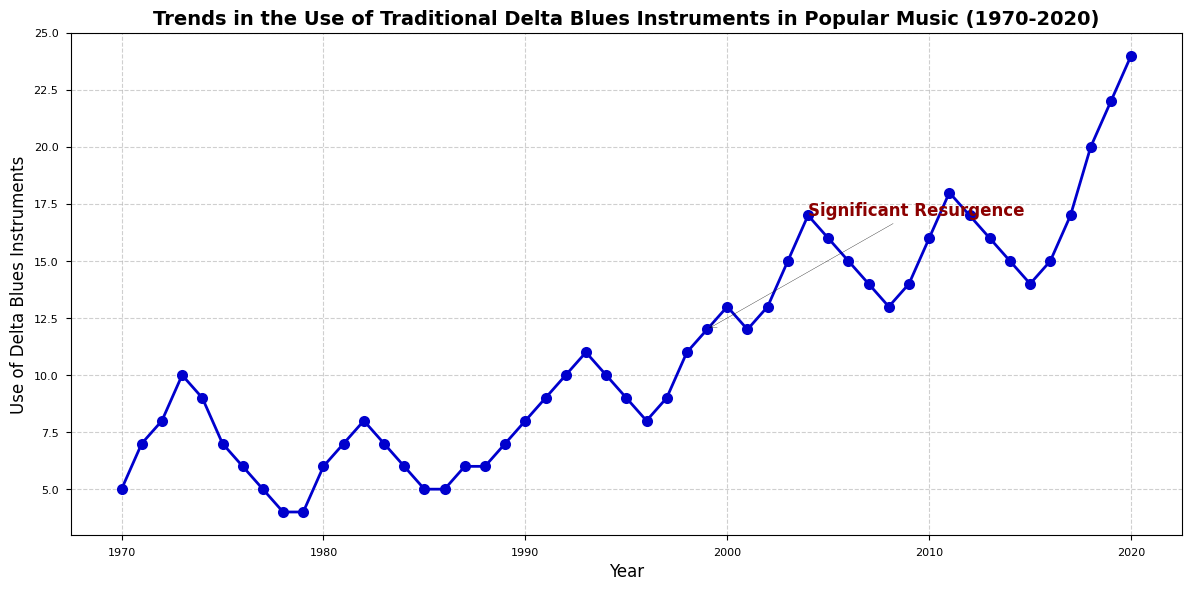What year had the highest use of Delta blues instruments? Looking at the chart, the year 2020 shows the highest point on the y-axis, indicating the highest use of Delta blues instruments.
Answer: 2020 In which year was there a significant resurgence noted in the use of Delta blues instruments? According to the annotation on the figure, the year 1999 is marked as the significant resurgence year.
Answer: 1999 By how much did the use of Delta blues instruments increase from 1978 to 1982? The use in 1978 was 4, and in 1982 it was 8. The difference between 8 and 4 is 4.
Answer: 4 Which year saw a greater increase in the use of Delta blues instruments: from 2000 to 2003 or from 2017 to 2020? From 2000 to 2003, the use increased from 13 to 15 (an increase of 2). From 2017 to 2020, it increased from 17 to 24 (an increase of 7). Thus, 2017 to 2020 saw a greater increase.
Answer: 2017 to 2020 What was the average use of Delta blues instruments in the first decade (1970-1979)? The values for 1970-1979 are: 5, 7, 8, 10, 9, 7, 6, 5, 4, 4. Summing these values gives 65, and there are 10 values. So, the average is 65/10 = 6.5.
Answer: 6.5 How did the use of Delta blues instruments change between 1989 and 1990? In 1989, the value was 7, and in 1990, it was 8. The use increased by 1.
Answer: Increased by 1 Is the trend from 2010 to 2015 increasing, decreasing, or fluctuating? From 2010 to 2015, the values are 16, 18, 17, 16, 15, 14. The trend is overall decreasing.
Answer: Decreasing What period had the most drastic increase in the use of Delta blues instruments? The most drastic increase appears to occur from 2016 (15) to 2018 (20), which is a difference of 5 within two years.
Answer: 2016 to 2018 How many times does the use of Delta blues instruments reach or surpass 20 units? The chart shows that the use reaches or surpasses 20 in the years 2018 (20), 2019 (22), and 2020 (24). So, this occurs 3 times.
Answer: 3 times 